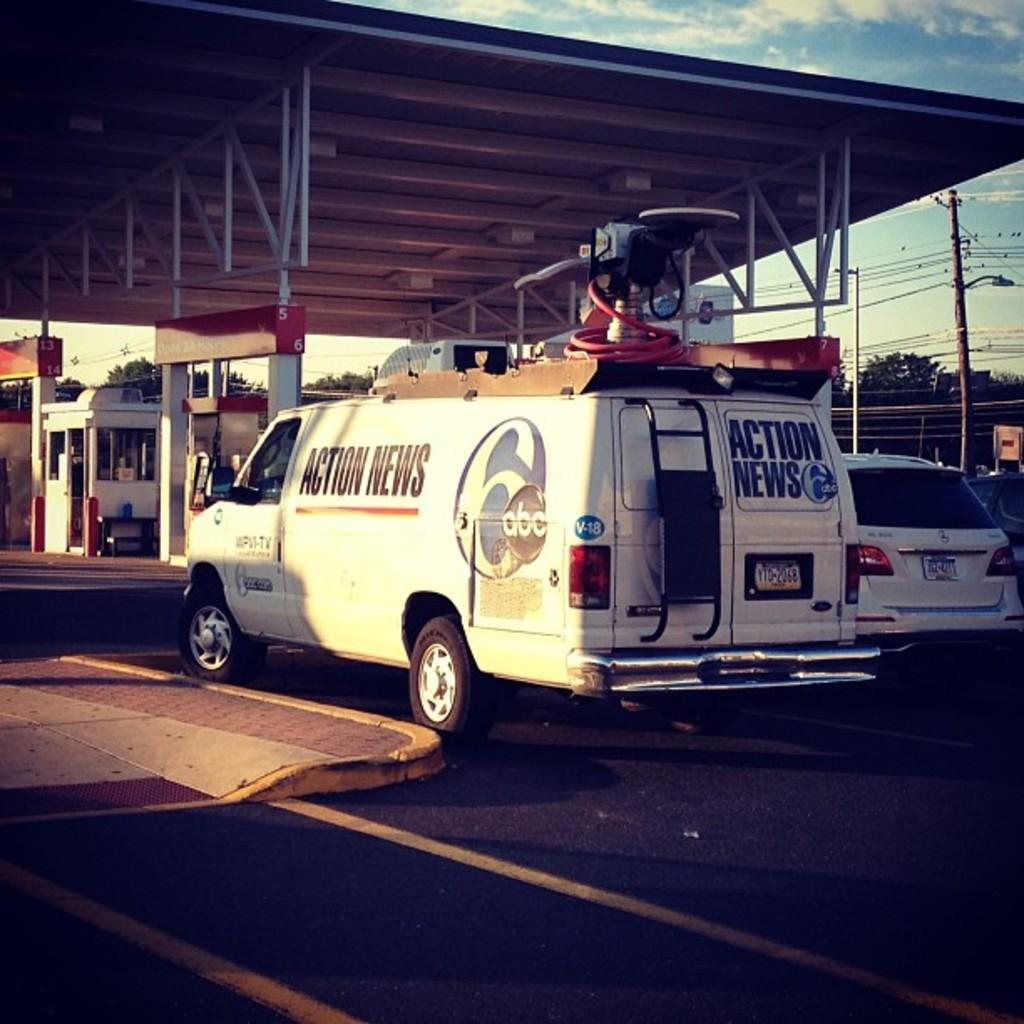<image>
Present a compact description of the photo's key features. A white van that reads Actions news six from the channel abc. 